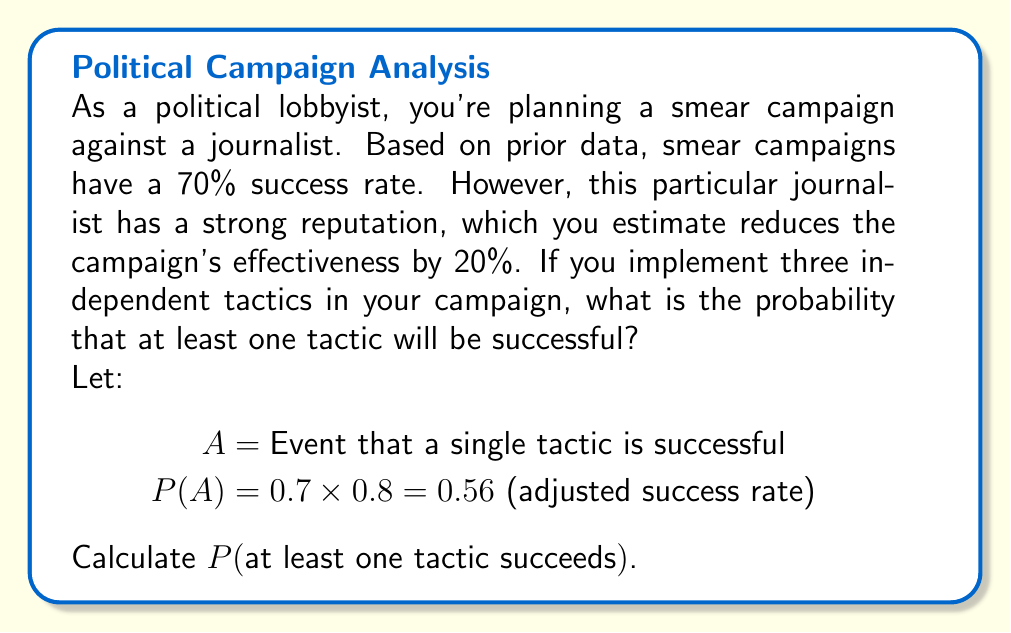What is the answer to this math problem? To solve this problem, we'll use the complement rule and the independence of events:

1) First, calculate the probability of a single tactic succeeding:
   $P(A) = 0.7 \times 0.8 = 0.56$

2) The probability we're looking for is the complement of all tactics failing:
   $P(\text{at least one succeeds}) = 1 - P(\text{all fail})$

3) Given independence, the probability of all three tactics failing is:
   $P(\text{all fail}) = (1 - P(A))^3$

4) Substitute the values:
   $P(\text{at least one succeeds}) = 1 - (1 - 0.56)^3$

5) Calculate:
   $= 1 - (0.44)^3$
   $= 1 - 0.085184$
   $= 0.914816$

6) Round to four decimal places:
   $= 0.9148$

Therefore, the probability that at least one tactic in the smear campaign will be successful is approximately 0.9148 or 91.48%.
Answer: 0.9148 